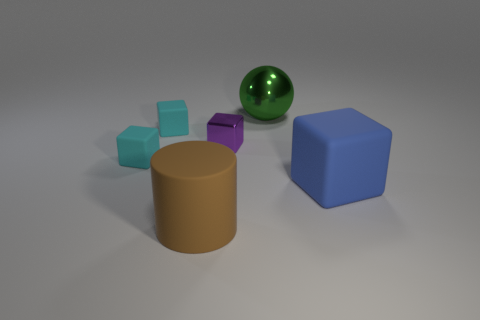There is a big thing that is behind the large matte thing that is to the right of the large object that is in front of the big blue matte block; what color is it?
Provide a succinct answer. Green. What color is the cylinder that is the same size as the green ball?
Your answer should be compact. Brown. Do the large matte cylinder and the cube that is on the right side of the big green object have the same color?
Offer a very short reply. No. There is a tiny thing that is on the right side of the small cyan rubber object behind the purple metal block; what is it made of?
Ensure brevity in your answer.  Metal. What number of things are both to the right of the large brown matte thing and in front of the green object?
Give a very brief answer. 2. What number of other objects are the same size as the purple metallic object?
Your answer should be very brief. 2. There is a cyan object behind the metallic block; is it the same shape as the big matte object left of the purple metal object?
Your answer should be very brief. No. Are there any blue rubber objects in front of the large green thing?
Your response must be concise. Yes. What is the color of the large thing that is the same shape as the small purple metallic object?
Make the answer very short. Blue. Is there any other thing that has the same shape as the small metal object?
Your response must be concise. Yes. 